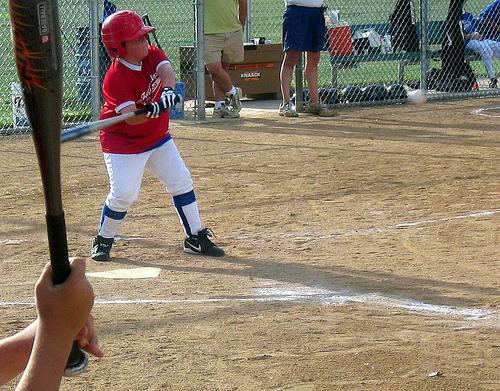What color are the tennis shoes?
Short answer required. Black. What color are the boy's pants?
Answer briefly. White. What color is the boy's helmet?
Answer briefly. Red. What is the boy doing?
Quick response, please. Batting. 